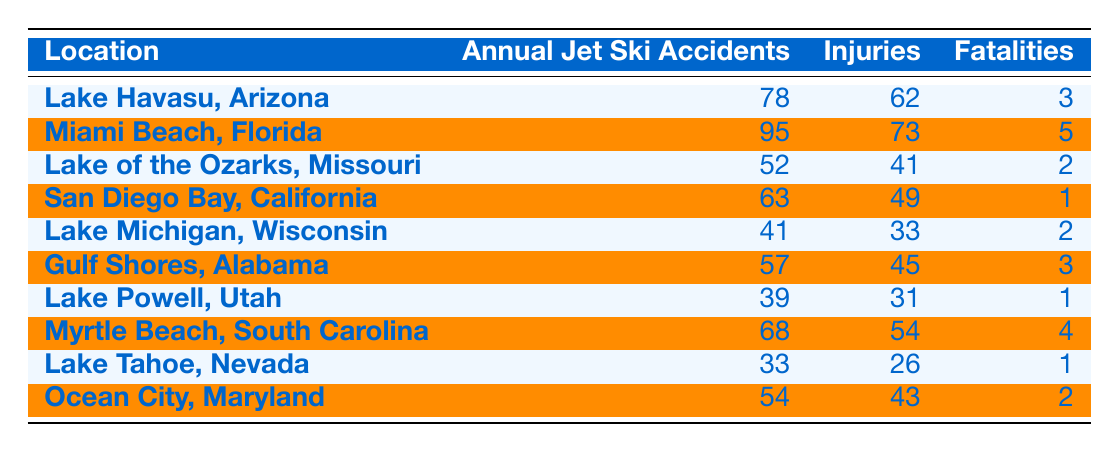What location has the highest number of annual jet ski accidents? From the table, Miami Beach, Florida has the highest number of annual jet ski accidents with a total of 95 accidents.
Answer: Miami Beach, Florida How many injuries occurred in San Diego Bay, California? According to the table, San Diego Bay, California had 49 injuries reported from the jet ski accidents.
Answer: 49 What is the total number of fatalities across all locations listed? To find the total fatalities, we sum the fatalities from each location: 3 + 5 + 2 + 1 + 2 + 3 + 1 + 4 + 1 + 2 = 24.
Answer: 24 Is it true that Lake Powell, Utah had more injuries than Lake Michigan, Wisconsin? Looking at the table, Lake Powell, Utah reported 31 injuries, while Lake Michigan, Wisconsin had 33 injuries. Therefore, the statement is false.
Answer: No What is the average number of annual jet ski accidents across all the locations? To find the average, sum the annual jet ski accidents: 78 + 95 + 52 + 63 + 41 + 57 + 39 + 68 + 33 + 54 =  580. Then divide by the number of locations, which is 10, resulting in an average of 580 / 10 = 58.
Answer: 58 Which location has the least fatalities, and how many were reported? By checking the fatalities listed, Lake Tahoe, Nevada has the least fatalities with only 1 reported death.
Answer: Lake Tahoe, Nevada; 1 How many locations reported more than 60 jet ski accidents annually? Reviewing the data, the locations with more than 60 annual jet ski accidents are Miami Beach, Florida (95), Lake Havasu, Arizona (78), San Diego Bay, California (63), and Myrtle Beach, South Carolina (68). Thus, there are 4 locations.
Answer: 4 What is the difference in the number of injuries between Gulf Shores, Alabama and Myrtle Beach, South Carolina? Gulf Shores, Alabama had 45 injuries and Myrtle Beach, South Carolina had 54 injuries. The difference is 54 - 45 = 9.
Answer: 9 What location had fewer accidents, Lake of the Ozarks, Missouri or Lake Michigan, Wisconsin? Lake of the Ozarks, Missouri had 52 accidents, while Lake Michigan, Wisconsin had 41 accidents. Therefore, Lake Michigan, Wisconsin had fewer accidents.
Answer: Lake Michigan, Wisconsin 